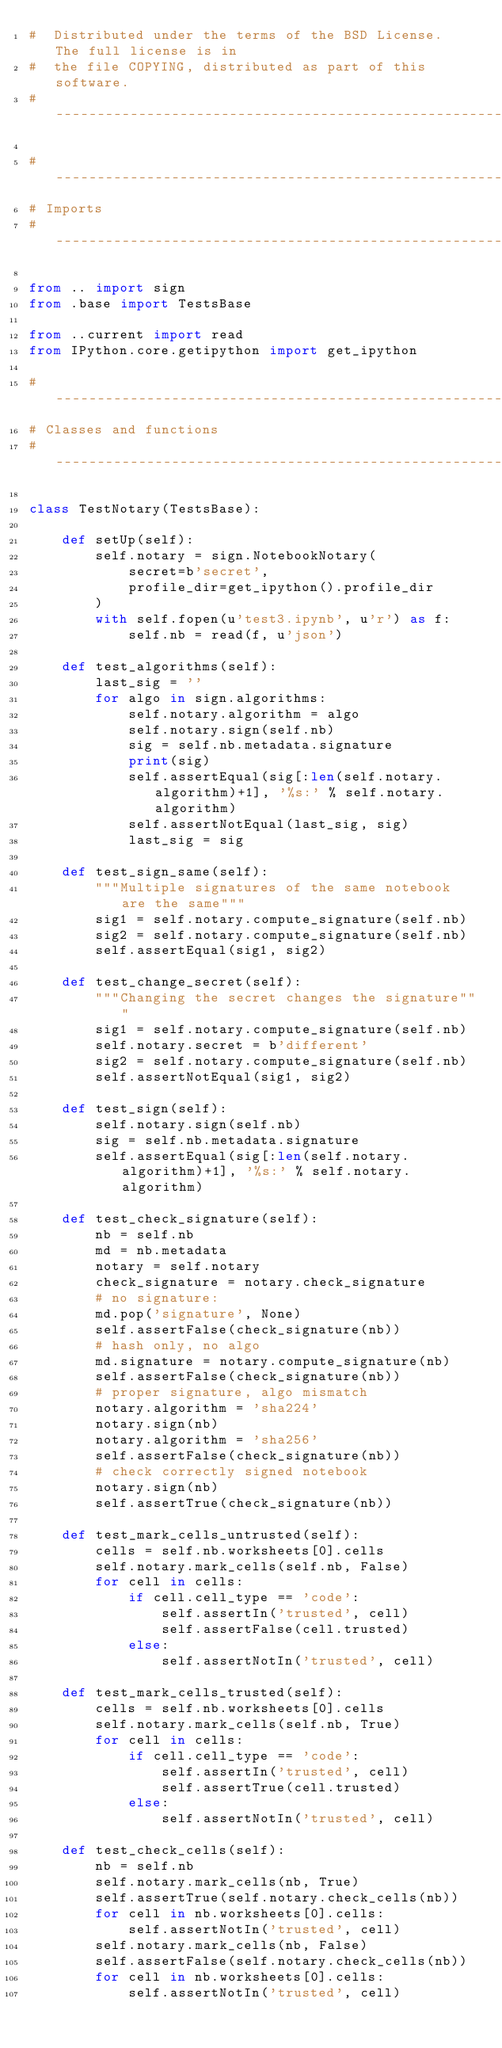<code> <loc_0><loc_0><loc_500><loc_500><_Python_>#  Distributed under the terms of the BSD License.  The full license is in
#  the file COPYING, distributed as part of this software.
#-----------------------------------------------------------------------------

#-----------------------------------------------------------------------------
# Imports
#-----------------------------------------------------------------------------

from .. import sign
from .base import TestsBase

from ..current import read
from IPython.core.getipython import get_ipython

#-----------------------------------------------------------------------------
# Classes and functions
#-----------------------------------------------------------------------------

class TestNotary(TestsBase):
    
    def setUp(self):
        self.notary = sign.NotebookNotary(
            secret=b'secret',
            profile_dir=get_ipython().profile_dir
        )
        with self.fopen(u'test3.ipynb', u'r') as f:
            self.nb = read(f, u'json')
    
    def test_algorithms(self):
        last_sig = ''
        for algo in sign.algorithms:
            self.notary.algorithm = algo
            self.notary.sign(self.nb)
            sig = self.nb.metadata.signature
            print(sig)
            self.assertEqual(sig[:len(self.notary.algorithm)+1], '%s:' % self.notary.algorithm)
            self.assertNotEqual(last_sig, sig)
            last_sig = sig
    
    def test_sign_same(self):
        """Multiple signatures of the same notebook are the same"""
        sig1 = self.notary.compute_signature(self.nb)
        sig2 = self.notary.compute_signature(self.nb)
        self.assertEqual(sig1, sig2)
    
    def test_change_secret(self):
        """Changing the secret changes the signature"""
        sig1 = self.notary.compute_signature(self.nb)
        self.notary.secret = b'different'
        sig2 = self.notary.compute_signature(self.nb)
        self.assertNotEqual(sig1, sig2)
    
    def test_sign(self):
        self.notary.sign(self.nb)
        sig = self.nb.metadata.signature
        self.assertEqual(sig[:len(self.notary.algorithm)+1], '%s:' % self.notary.algorithm)
    
    def test_check_signature(self):
        nb = self.nb
        md = nb.metadata
        notary = self.notary
        check_signature = notary.check_signature
        # no signature:
        md.pop('signature', None)
        self.assertFalse(check_signature(nb))
        # hash only, no algo
        md.signature = notary.compute_signature(nb)
        self.assertFalse(check_signature(nb))
        # proper signature, algo mismatch
        notary.algorithm = 'sha224'
        notary.sign(nb)
        notary.algorithm = 'sha256'
        self.assertFalse(check_signature(nb))
        # check correctly signed notebook
        notary.sign(nb)
        self.assertTrue(check_signature(nb))
    
    def test_mark_cells_untrusted(self):
        cells = self.nb.worksheets[0].cells
        self.notary.mark_cells(self.nb, False)
        for cell in cells:
            if cell.cell_type == 'code':
                self.assertIn('trusted', cell)
                self.assertFalse(cell.trusted)
            else:
                self.assertNotIn('trusted', cell)
    
    def test_mark_cells_trusted(self):
        cells = self.nb.worksheets[0].cells
        self.notary.mark_cells(self.nb, True)
        for cell in cells:
            if cell.cell_type == 'code':
                self.assertIn('trusted', cell)
                self.assertTrue(cell.trusted)
            else:
                self.assertNotIn('trusted', cell)
    
    def test_check_cells(self):
        nb = self.nb
        self.notary.mark_cells(nb, True)
        self.assertTrue(self.notary.check_cells(nb))
        for cell in nb.worksheets[0].cells:
            self.assertNotIn('trusted', cell)
        self.notary.mark_cells(nb, False)
        self.assertFalse(self.notary.check_cells(nb))
        for cell in nb.worksheets[0].cells:
            self.assertNotIn('trusted', cell)

</code> 